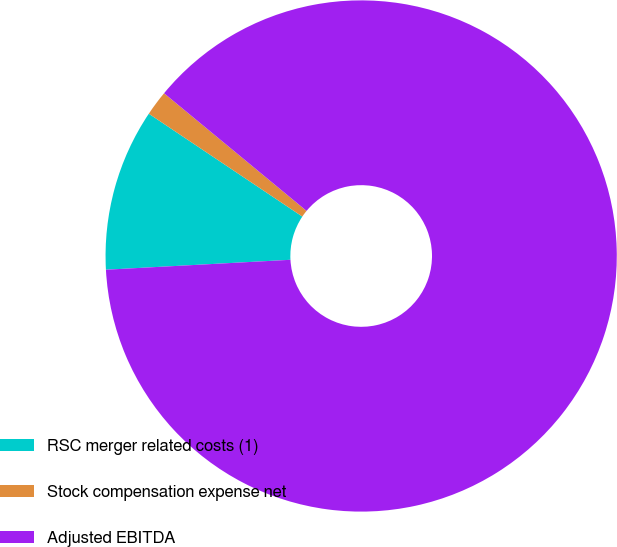<chart> <loc_0><loc_0><loc_500><loc_500><pie_chart><fcel>RSC merger related costs (1)<fcel>Stock compensation expense net<fcel>Adjusted EBITDA<nl><fcel>10.25%<fcel>1.59%<fcel>88.16%<nl></chart> 